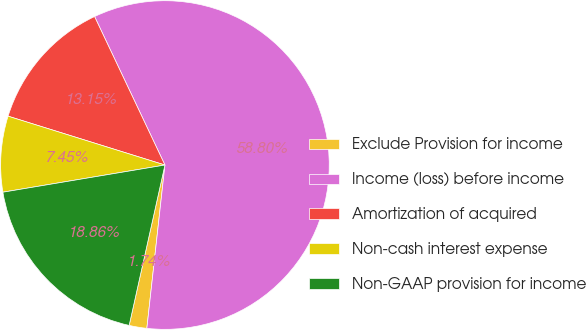Convert chart. <chart><loc_0><loc_0><loc_500><loc_500><pie_chart><fcel>Exclude Provision for income<fcel>Income (loss) before income<fcel>Amortization of acquired<fcel>Non-cash interest expense<fcel>Non-GAAP provision for income<nl><fcel>1.74%<fcel>58.8%<fcel>13.15%<fcel>7.45%<fcel>18.86%<nl></chart> 